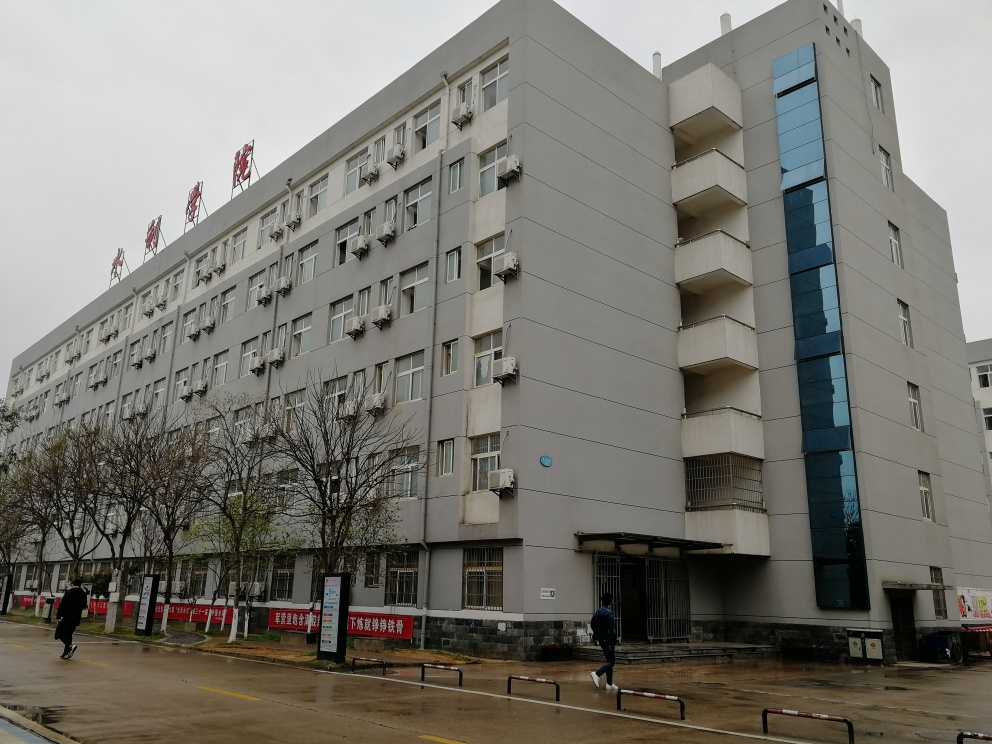Can you tell what the weather is like in this image? The sky is overcast, suggesting a cloudy day. The lighting is diffused, with no distinct shadows, indicating an absence of direct sunlight. The attire of the person in the image suggests it is not too warm or cold. The ground appears to be wet, which could signify recent rain. 